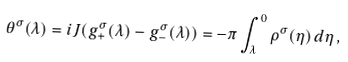<formula> <loc_0><loc_0><loc_500><loc_500>\theta ^ { \sigma } ( \lambda ) = i J ( g ^ { \sigma } _ { + } ( \lambda ) - g ^ { \sigma } _ { - } ( \lambda ) ) = - \pi \int _ { \lambda } ^ { 0 } \rho ^ { \sigma } ( \eta ) \, d \eta \, ,</formula> 